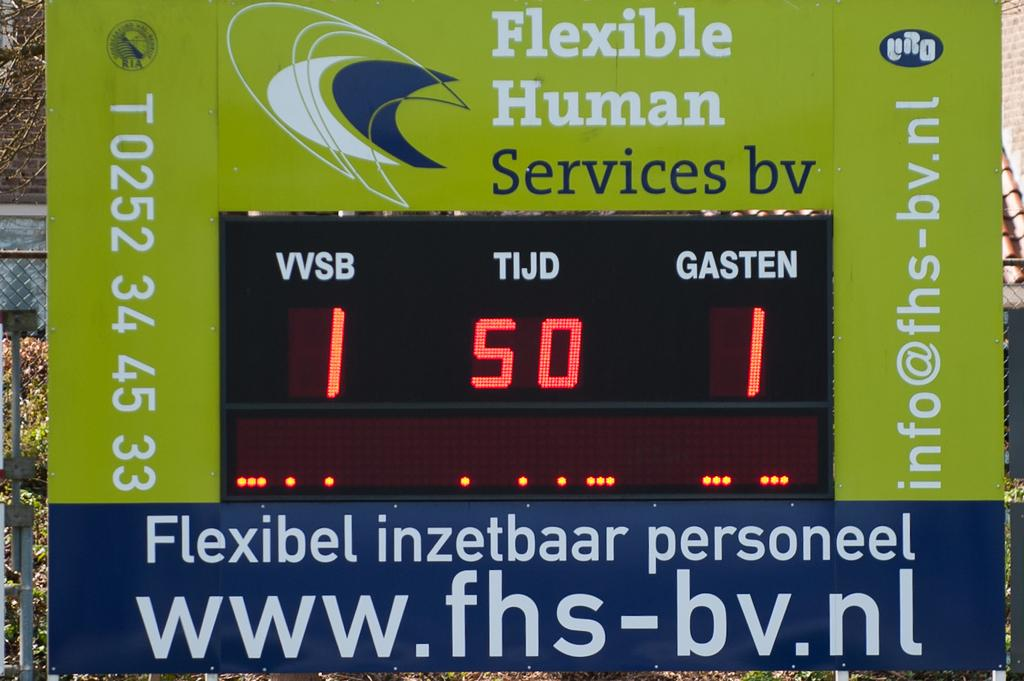Provide a one-sentence caption for the provided image. A tied game of 1 to 1 displayed on the flexible human services dashboard. 